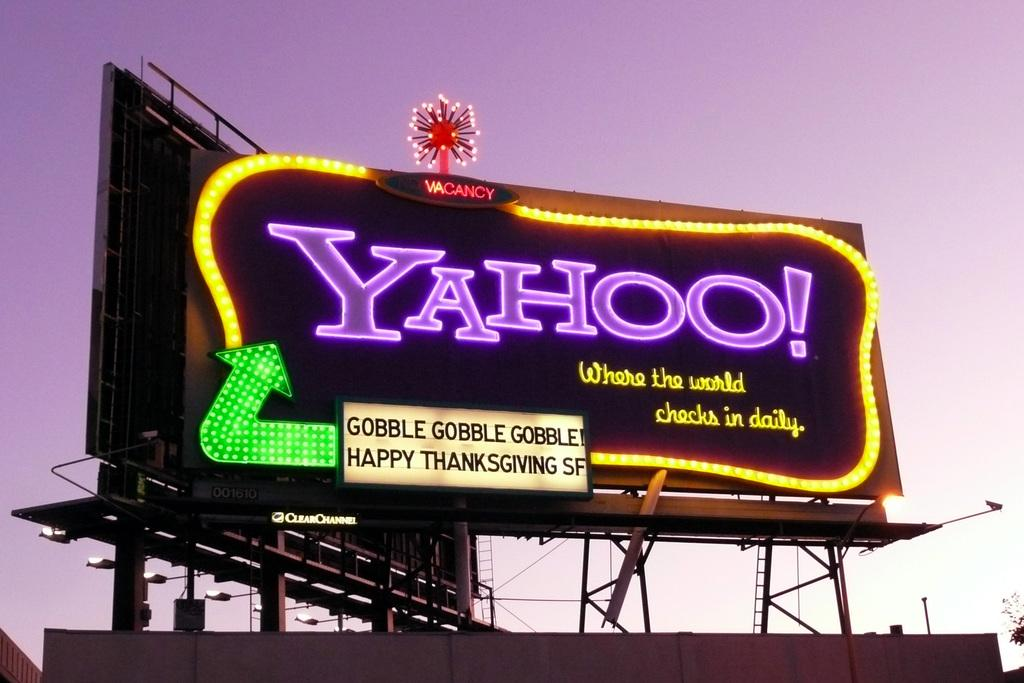<image>
Provide a brief description of the given image. YAHOO Billboard sign that says Gobble Gobble Gobble Happy Thanksgiving SF, Where the World Checks in daily. 